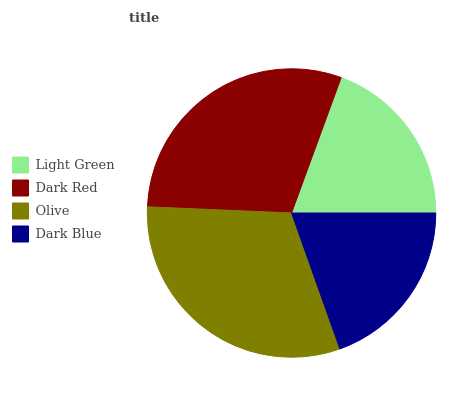Is Light Green the minimum?
Answer yes or no. Yes. Is Olive the maximum?
Answer yes or no. Yes. Is Dark Red the minimum?
Answer yes or no. No. Is Dark Red the maximum?
Answer yes or no. No. Is Dark Red greater than Light Green?
Answer yes or no. Yes. Is Light Green less than Dark Red?
Answer yes or no. Yes. Is Light Green greater than Dark Red?
Answer yes or no. No. Is Dark Red less than Light Green?
Answer yes or no. No. Is Dark Red the high median?
Answer yes or no. Yes. Is Dark Blue the low median?
Answer yes or no. Yes. Is Light Green the high median?
Answer yes or no. No. Is Olive the low median?
Answer yes or no. No. 